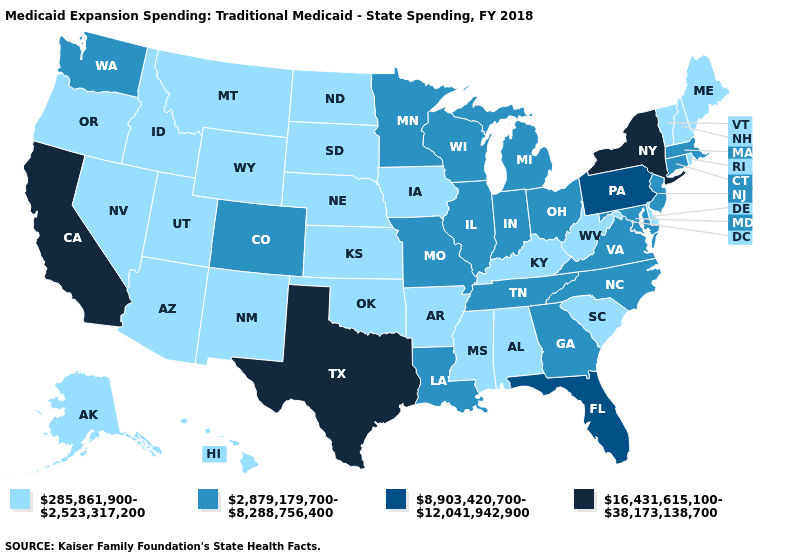Among the states that border Indiana , which have the highest value?
Be succinct. Illinois, Michigan, Ohio. Which states hav the highest value in the South?
Short answer required. Texas. Which states have the highest value in the USA?
Concise answer only. California, New York, Texas. Name the states that have a value in the range 2,879,179,700-8,288,756,400?
Keep it brief. Colorado, Connecticut, Georgia, Illinois, Indiana, Louisiana, Maryland, Massachusetts, Michigan, Minnesota, Missouri, New Jersey, North Carolina, Ohio, Tennessee, Virginia, Washington, Wisconsin. Which states have the highest value in the USA?
Concise answer only. California, New York, Texas. Does Massachusetts have a lower value than New Jersey?
Concise answer only. No. What is the value of Louisiana?
Concise answer only. 2,879,179,700-8,288,756,400. What is the highest value in states that border Mississippi?
Short answer required. 2,879,179,700-8,288,756,400. Does Maine have the lowest value in the Northeast?
Keep it brief. Yes. Name the states that have a value in the range 285,861,900-2,523,317,200?
Give a very brief answer. Alabama, Alaska, Arizona, Arkansas, Delaware, Hawaii, Idaho, Iowa, Kansas, Kentucky, Maine, Mississippi, Montana, Nebraska, Nevada, New Hampshire, New Mexico, North Dakota, Oklahoma, Oregon, Rhode Island, South Carolina, South Dakota, Utah, Vermont, West Virginia, Wyoming. What is the lowest value in the USA?
Write a very short answer. 285,861,900-2,523,317,200. Does Oregon have the lowest value in the USA?
Write a very short answer. Yes. Among the states that border New Hampshire , does Maine have the lowest value?
Keep it brief. Yes. 